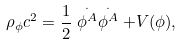Convert formula to latex. <formula><loc_0><loc_0><loc_500><loc_500>\rho _ { \phi } c ^ { 2 } = \frac { 1 } { 2 } \stackrel { . } { \phi ^ { A } } \stackrel { . } { \phi ^ { A } } + V ( \phi ) ,</formula> 